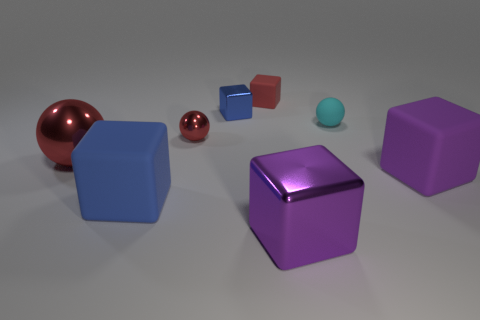There is a big shiny ball; is its color the same as the metallic block that is in front of the rubber sphere?
Keep it short and to the point. No. There is a blue cube that is in front of the tiny blue metal object behind the blue block on the left side of the small metallic cube; what is its size?
Your answer should be very brief. Large. How many small shiny balls are the same color as the large ball?
Ensure brevity in your answer.  1. How many objects are tiny yellow matte cylinders or objects behind the matte sphere?
Give a very brief answer. 2. The small matte block has what color?
Keep it short and to the point. Red. The metal cube behind the big red metallic object is what color?
Keep it short and to the point. Blue. How many tiny metal objects are in front of the big block that is on the left side of the tiny blue shiny thing?
Offer a terse response. 0. There is a blue matte block; is it the same size as the red metallic sphere that is on the right side of the blue matte object?
Provide a succinct answer. No. Are there any metal cylinders of the same size as the purple rubber thing?
Make the answer very short. No. How many objects are red spheres or red cubes?
Offer a very short reply. 3. 